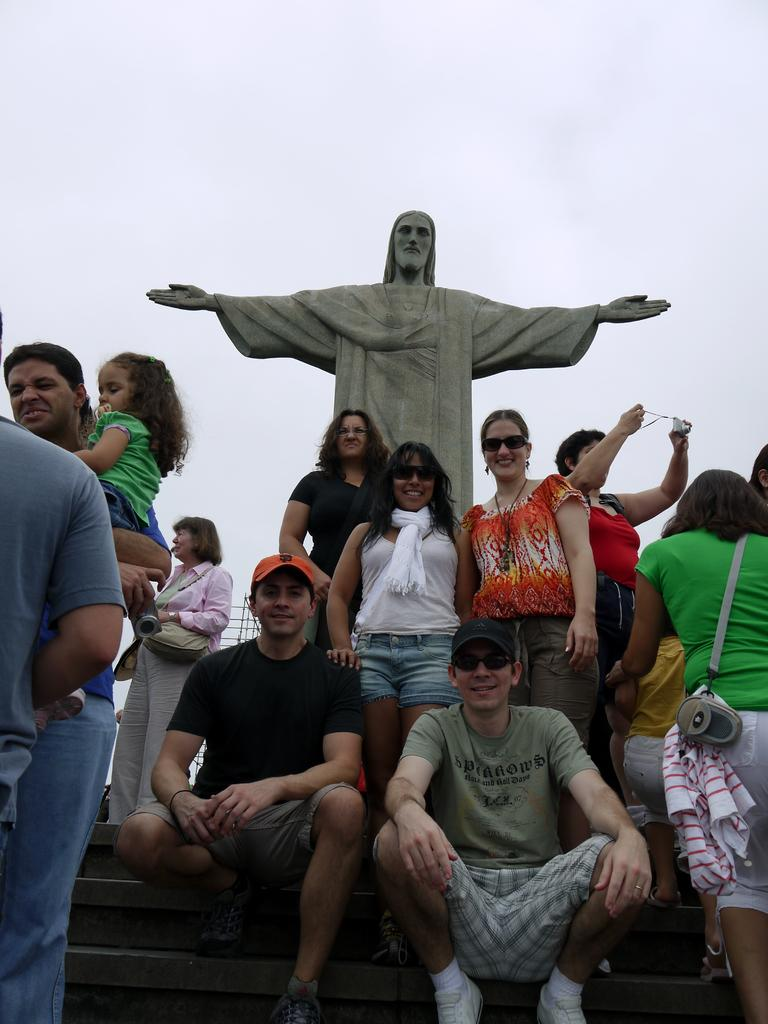What is the main subject of the image? There is a Jesus statue in the image. Are there any people in the image? Yes, there is a group of people in front of the statue. What are some of the people in the group doing? Some people in the group are posing for a photo. What type of collar can be seen on the beetle in the image? There is no beetle present in the image, and therefore no collar can be seen. 